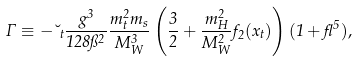Convert formula to latex. <formula><loc_0><loc_0><loc_500><loc_500>\Gamma \equiv - \lambda _ { t } \frac { g ^ { 3 } } { 1 2 8 \pi ^ { 2 } } \frac { m _ { t } ^ { 2 } m _ { s } } { M _ { W } ^ { 3 } } \left ( \frac { 3 } { 2 } + \frac { m _ { H } ^ { 2 } } { M _ { W } ^ { 2 } } f _ { 2 } ( x _ { t } ) \right ) ( 1 + \gamma ^ { 5 } ) ,</formula> 